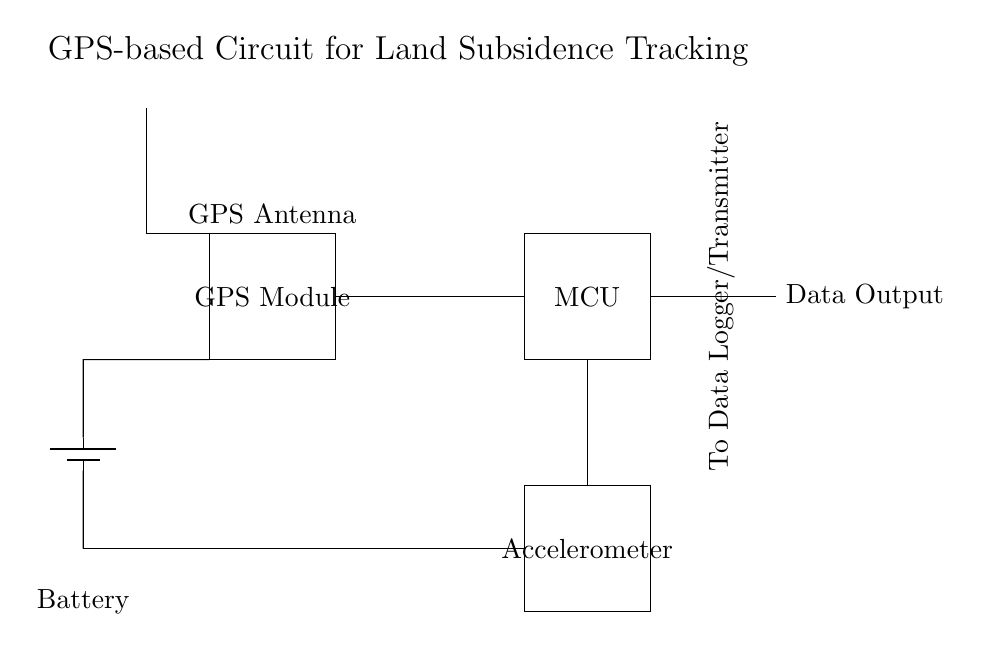What is the function of the GPS module? The GPS module is responsible for receiving satellite signals to determine the geographical location of the device, which is essential for tracking land subsidence accurately.
Answer: Tracking location What type of power source is used in this circuit? The circuit uses a battery as its power supply, indicated by the battery symbol connected to the microcontroller and other components.
Answer: Battery How many main components are in this circuit? The circuit contains four main components: a GPS module, a microcontroller, an accelerometer, and a power supply.
Answer: Four What type of data does the microcontroller output? The microcontroller outputs data typically related to location and movement, which can include coordinates and changes in the position detected by the accelerometer.
Answer: Data Output What does the accelerometer measure? The accelerometer measures acceleration forces, allowing detection of movement or changes in position, which is crucial for assessing land subsidence.
Answer: Acceleration forces Why is an antenna included in the circuit? The antenna is included to enhance the GPS module's ability to receive signals from satellites, improving the accuracy and reliability of the location tracking.
Answer: To receive GPS signals How is data exported from the microcontroller? Data is exported from the microcontroller through a specified output connection, designed to send the processed information to a data logger or transmitter.
Answer: Through data output 